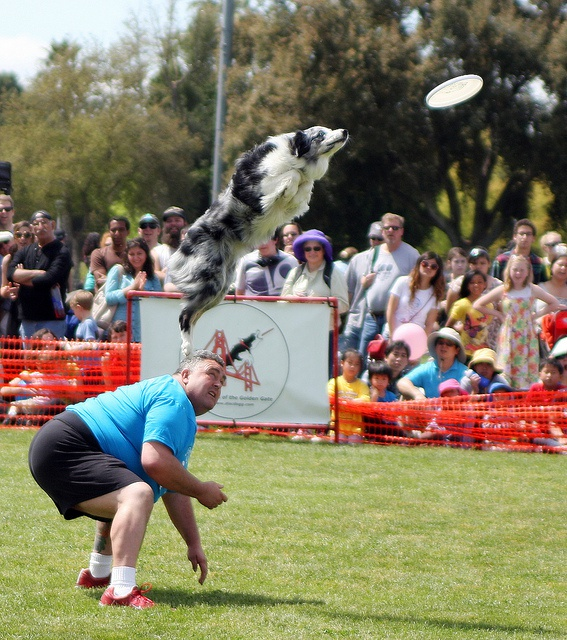Describe the objects in this image and their specific colors. I can see people in white, brown, darkgray, tan, and red tones, people in white, black, maroon, gray, and lightgray tones, dog in white, gray, black, darkgray, and lightgray tones, people in white, darkgray, gray, tan, and lightgray tones, and people in white, black, gray, navy, and maroon tones in this image. 